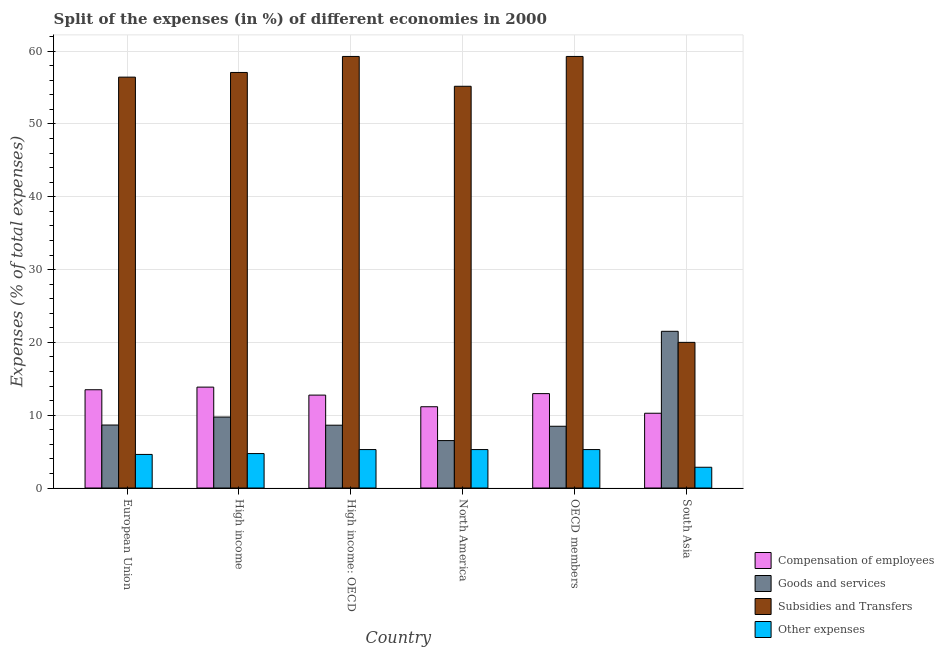How many different coloured bars are there?
Provide a succinct answer. 4. Are the number of bars per tick equal to the number of legend labels?
Offer a terse response. Yes. How many bars are there on the 6th tick from the left?
Give a very brief answer. 4. What is the percentage of amount spent on subsidies in OECD members?
Ensure brevity in your answer.  59.27. Across all countries, what is the maximum percentage of amount spent on subsidies?
Your answer should be very brief. 59.27. Across all countries, what is the minimum percentage of amount spent on goods and services?
Ensure brevity in your answer.  6.51. In which country was the percentage of amount spent on subsidies maximum?
Make the answer very short. High income: OECD. In which country was the percentage of amount spent on goods and services minimum?
Offer a very short reply. North America. What is the total percentage of amount spent on subsidies in the graph?
Your answer should be compact. 307.22. What is the difference between the percentage of amount spent on compensation of employees in North America and that in South Asia?
Your answer should be very brief. 0.89. What is the difference between the percentage of amount spent on goods and services in High income: OECD and the percentage of amount spent on compensation of employees in North America?
Offer a very short reply. -2.53. What is the average percentage of amount spent on goods and services per country?
Make the answer very short. 10.59. What is the difference between the percentage of amount spent on compensation of employees and percentage of amount spent on subsidies in European Union?
Your response must be concise. -42.94. In how many countries, is the percentage of amount spent on compensation of employees greater than 26 %?
Offer a terse response. 0. What is the ratio of the percentage of amount spent on goods and services in High income to that in High income: OECD?
Keep it short and to the point. 1.13. Is the difference between the percentage of amount spent on goods and services in High income and High income: OECD greater than the difference between the percentage of amount spent on other expenses in High income and High income: OECD?
Ensure brevity in your answer.  Yes. What is the difference between the highest and the lowest percentage of amount spent on other expenses?
Ensure brevity in your answer.  2.43. In how many countries, is the percentage of amount spent on goods and services greater than the average percentage of amount spent on goods and services taken over all countries?
Give a very brief answer. 1. What does the 4th bar from the left in North America represents?
Provide a short and direct response. Other expenses. What does the 4th bar from the right in North America represents?
Your answer should be compact. Compensation of employees. How many bars are there?
Give a very brief answer. 24. Are all the bars in the graph horizontal?
Keep it short and to the point. No. How many countries are there in the graph?
Your answer should be very brief. 6. What is the difference between two consecutive major ticks on the Y-axis?
Your response must be concise. 10. Are the values on the major ticks of Y-axis written in scientific E-notation?
Give a very brief answer. No. Does the graph contain grids?
Provide a short and direct response. Yes. What is the title of the graph?
Provide a succinct answer. Split of the expenses (in %) of different economies in 2000. What is the label or title of the Y-axis?
Keep it short and to the point. Expenses (% of total expenses). What is the Expenses (% of total expenses) of Compensation of employees in European Union?
Offer a very short reply. 13.5. What is the Expenses (% of total expenses) of Goods and services in European Union?
Offer a terse response. 8.65. What is the Expenses (% of total expenses) in Subsidies and Transfers in European Union?
Your answer should be very brief. 56.43. What is the Expenses (% of total expenses) of Other expenses in European Union?
Provide a succinct answer. 4.61. What is the Expenses (% of total expenses) of Compensation of employees in High income?
Keep it short and to the point. 13.86. What is the Expenses (% of total expenses) of Goods and services in High income?
Ensure brevity in your answer.  9.75. What is the Expenses (% of total expenses) in Subsidies and Transfers in High income?
Give a very brief answer. 57.07. What is the Expenses (% of total expenses) in Other expenses in High income?
Offer a terse response. 4.73. What is the Expenses (% of total expenses) in Compensation of employees in High income: OECD?
Provide a short and direct response. 12.76. What is the Expenses (% of total expenses) in Goods and services in High income: OECD?
Provide a succinct answer. 8.63. What is the Expenses (% of total expenses) of Subsidies and Transfers in High income: OECD?
Your response must be concise. 59.27. What is the Expenses (% of total expenses) in Other expenses in High income: OECD?
Keep it short and to the point. 5.28. What is the Expenses (% of total expenses) of Compensation of employees in North America?
Your answer should be very brief. 11.16. What is the Expenses (% of total expenses) of Goods and services in North America?
Keep it short and to the point. 6.51. What is the Expenses (% of total expenses) in Subsidies and Transfers in North America?
Give a very brief answer. 55.18. What is the Expenses (% of total expenses) in Other expenses in North America?
Make the answer very short. 5.28. What is the Expenses (% of total expenses) of Compensation of employees in OECD members?
Provide a short and direct response. 12.96. What is the Expenses (% of total expenses) in Goods and services in OECD members?
Ensure brevity in your answer.  8.48. What is the Expenses (% of total expenses) of Subsidies and Transfers in OECD members?
Your answer should be compact. 59.27. What is the Expenses (% of total expenses) of Other expenses in OECD members?
Give a very brief answer. 5.28. What is the Expenses (% of total expenses) in Compensation of employees in South Asia?
Provide a succinct answer. 10.27. What is the Expenses (% of total expenses) of Goods and services in South Asia?
Your answer should be compact. 21.52. What is the Expenses (% of total expenses) in Subsidies and Transfers in South Asia?
Offer a terse response. 20. What is the Expenses (% of total expenses) in Other expenses in South Asia?
Keep it short and to the point. 2.85. Across all countries, what is the maximum Expenses (% of total expenses) of Compensation of employees?
Provide a succinct answer. 13.86. Across all countries, what is the maximum Expenses (% of total expenses) in Goods and services?
Provide a short and direct response. 21.52. Across all countries, what is the maximum Expenses (% of total expenses) in Subsidies and Transfers?
Your answer should be very brief. 59.27. Across all countries, what is the maximum Expenses (% of total expenses) in Other expenses?
Provide a succinct answer. 5.28. Across all countries, what is the minimum Expenses (% of total expenses) of Compensation of employees?
Give a very brief answer. 10.27. Across all countries, what is the minimum Expenses (% of total expenses) of Goods and services?
Offer a very short reply. 6.51. Across all countries, what is the minimum Expenses (% of total expenses) of Subsidies and Transfers?
Provide a short and direct response. 20. Across all countries, what is the minimum Expenses (% of total expenses) in Other expenses?
Keep it short and to the point. 2.85. What is the total Expenses (% of total expenses) of Compensation of employees in the graph?
Provide a succinct answer. 74.51. What is the total Expenses (% of total expenses) in Goods and services in the graph?
Your answer should be compact. 63.54. What is the total Expenses (% of total expenses) in Subsidies and Transfers in the graph?
Offer a terse response. 307.22. What is the total Expenses (% of total expenses) of Other expenses in the graph?
Keep it short and to the point. 28.03. What is the difference between the Expenses (% of total expenses) of Compensation of employees in European Union and that in High income?
Your answer should be very brief. -0.36. What is the difference between the Expenses (% of total expenses) of Goods and services in European Union and that in High income?
Keep it short and to the point. -1.1. What is the difference between the Expenses (% of total expenses) in Subsidies and Transfers in European Union and that in High income?
Provide a succinct answer. -0.64. What is the difference between the Expenses (% of total expenses) of Other expenses in European Union and that in High income?
Ensure brevity in your answer.  -0.12. What is the difference between the Expenses (% of total expenses) of Compensation of employees in European Union and that in High income: OECD?
Keep it short and to the point. 0.74. What is the difference between the Expenses (% of total expenses) in Goods and services in European Union and that in High income: OECD?
Provide a short and direct response. 0.02. What is the difference between the Expenses (% of total expenses) of Subsidies and Transfers in European Union and that in High income: OECD?
Your answer should be very brief. -2.84. What is the difference between the Expenses (% of total expenses) in Other expenses in European Union and that in High income: OECD?
Your response must be concise. -0.67. What is the difference between the Expenses (% of total expenses) in Compensation of employees in European Union and that in North America?
Keep it short and to the point. 2.33. What is the difference between the Expenses (% of total expenses) in Goods and services in European Union and that in North America?
Your answer should be very brief. 2.14. What is the difference between the Expenses (% of total expenses) in Subsidies and Transfers in European Union and that in North America?
Offer a terse response. 1.26. What is the difference between the Expenses (% of total expenses) of Other expenses in European Union and that in North America?
Your answer should be compact. -0.67. What is the difference between the Expenses (% of total expenses) in Compensation of employees in European Union and that in OECD members?
Provide a short and direct response. 0.53. What is the difference between the Expenses (% of total expenses) of Goods and services in European Union and that in OECD members?
Offer a terse response. 0.17. What is the difference between the Expenses (% of total expenses) of Subsidies and Transfers in European Union and that in OECD members?
Provide a short and direct response. -2.84. What is the difference between the Expenses (% of total expenses) in Other expenses in European Union and that in OECD members?
Your answer should be very brief. -0.67. What is the difference between the Expenses (% of total expenses) of Compensation of employees in European Union and that in South Asia?
Offer a very short reply. 3.23. What is the difference between the Expenses (% of total expenses) of Goods and services in European Union and that in South Asia?
Offer a terse response. -12.87. What is the difference between the Expenses (% of total expenses) in Subsidies and Transfers in European Union and that in South Asia?
Your answer should be very brief. 36.43. What is the difference between the Expenses (% of total expenses) in Other expenses in European Union and that in South Asia?
Make the answer very short. 1.76. What is the difference between the Expenses (% of total expenses) in Compensation of employees in High income and that in High income: OECD?
Make the answer very short. 1.1. What is the difference between the Expenses (% of total expenses) of Goods and services in High income and that in High income: OECD?
Offer a very short reply. 1.12. What is the difference between the Expenses (% of total expenses) in Subsidies and Transfers in High income and that in High income: OECD?
Provide a short and direct response. -2.2. What is the difference between the Expenses (% of total expenses) of Other expenses in High income and that in High income: OECD?
Provide a short and direct response. -0.55. What is the difference between the Expenses (% of total expenses) of Compensation of employees in High income and that in North America?
Ensure brevity in your answer.  2.7. What is the difference between the Expenses (% of total expenses) of Goods and services in High income and that in North America?
Provide a succinct answer. 3.23. What is the difference between the Expenses (% of total expenses) of Subsidies and Transfers in High income and that in North America?
Offer a very short reply. 1.9. What is the difference between the Expenses (% of total expenses) of Other expenses in High income and that in North America?
Offer a very short reply. -0.55. What is the difference between the Expenses (% of total expenses) in Compensation of employees in High income and that in OECD members?
Your answer should be compact. 0.89. What is the difference between the Expenses (% of total expenses) of Goods and services in High income and that in OECD members?
Offer a terse response. 1.27. What is the difference between the Expenses (% of total expenses) in Subsidies and Transfers in High income and that in OECD members?
Provide a succinct answer. -2.2. What is the difference between the Expenses (% of total expenses) in Other expenses in High income and that in OECD members?
Keep it short and to the point. -0.55. What is the difference between the Expenses (% of total expenses) of Compensation of employees in High income and that in South Asia?
Make the answer very short. 3.59. What is the difference between the Expenses (% of total expenses) of Goods and services in High income and that in South Asia?
Make the answer very short. -11.77. What is the difference between the Expenses (% of total expenses) of Subsidies and Transfers in High income and that in South Asia?
Your answer should be very brief. 37.07. What is the difference between the Expenses (% of total expenses) in Other expenses in High income and that in South Asia?
Provide a short and direct response. 1.88. What is the difference between the Expenses (% of total expenses) of Compensation of employees in High income: OECD and that in North America?
Your answer should be compact. 1.6. What is the difference between the Expenses (% of total expenses) in Goods and services in High income: OECD and that in North America?
Make the answer very short. 2.11. What is the difference between the Expenses (% of total expenses) in Subsidies and Transfers in High income: OECD and that in North America?
Give a very brief answer. 4.1. What is the difference between the Expenses (% of total expenses) in Other expenses in High income: OECD and that in North America?
Offer a very short reply. 0. What is the difference between the Expenses (% of total expenses) in Compensation of employees in High income: OECD and that in OECD members?
Make the answer very short. -0.2. What is the difference between the Expenses (% of total expenses) of Goods and services in High income: OECD and that in OECD members?
Ensure brevity in your answer.  0.15. What is the difference between the Expenses (% of total expenses) in Other expenses in High income: OECD and that in OECD members?
Your answer should be compact. 0. What is the difference between the Expenses (% of total expenses) in Compensation of employees in High income: OECD and that in South Asia?
Ensure brevity in your answer.  2.49. What is the difference between the Expenses (% of total expenses) of Goods and services in High income: OECD and that in South Asia?
Provide a succinct answer. -12.89. What is the difference between the Expenses (% of total expenses) of Subsidies and Transfers in High income: OECD and that in South Asia?
Ensure brevity in your answer.  39.27. What is the difference between the Expenses (% of total expenses) of Other expenses in High income: OECD and that in South Asia?
Offer a terse response. 2.43. What is the difference between the Expenses (% of total expenses) in Compensation of employees in North America and that in OECD members?
Provide a succinct answer. -1.8. What is the difference between the Expenses (% of total expenses) of Goods and services in North America and that in OECD members?
Ensure brevity in your answer.  -1.97. What is the difference between the Expenses (% of total expenses) in Subsidies and Transfers in North America and that in OECD members?
Make the answer very short. -4.1. What is the difference between the Expenses (% of total expenses) in Compensation of employees in North America and that in South Asia?
Offer a terse response. 0.89. What is the difference between the Expenses (% of total expenses) in Goods and services in North America and that in South Asia?
Make the answer very short. -15.01. What is the difference between the Expenses (% of total expenses) in Subsidies and Transfers in North America and that in South Asia?
Offer a very short reply. 35.17. What is the difference between the Expenses (% of total expenses) of Other expenses in North America and that in South Asia?
Offer a very short reply. 2.43. What is the difference between the Expenses (% of total expenses) of Compensation of employees in OECD members and that in South Asia?
Provide a succinct answer. 2.69. What is the difference between the Expenses (% of total expenses) in Goods and services in OECD members and that in South Asia?
Your answer should be compact. -13.04. What is the difference between the Expenses (% of total expenses) of Subsidies and Transfers in OECD members and that in South Asia?
Your response must be concise. 39.27. What is the difference between the Expenses (% of total expenses) of Other expenses in OECD members and that in South Asia?
Give a very brief answer. 2.43. What is the difference between the Expenses (% of total expenses) in Compensation of employees in European Union and the Expenses (% of total expenses) in Goods and services in High income?
Keep it short and to the point. 3.75. What is the difference between the Expenses (% of total expenses) in Compensation of employees in European Union and the Expenses (% of total expenses) in Subsidies and Transfers in High income?
Provide a short and direct response. -43.58. What is the difference between the Expenses (% of total expenses) in Compensation of employees in European Union and the Expenses (% of total expenses) in Other expenses in High income?
Keep it short and to the point. 8.77. What is the difference between the Expenses (% of total expenses) in Goods and services in European Union and the Expenses (% of total expenses) in Subsidies and Transfers in High income?
Your answer should be very brief. -48.42. What is the difference between the Expenses (% of total expenses) of Goods and services in European Union and the Expenses (% of total expenses) of Other expenses in High income?
Provide a succinct answer. 3.92. What is the difference between the Expenses (% of total expenses) in Subsidies and Transfers in European Union and the Expenses (% of total expenses) in Other expenses in High income?
Offer a terse response. 51.7. What is the difference between the Expenses (% of total expenses) in Compensation of employees in European Union and the Expenses (% of total expenses) in Goods and services in High income: OECD?
Offer a very short reply. 4.87. What is the difference between the Expenses (% of total expenses) of Compensation of employees in European Union and the Expenses (% of total expenses) of Subsidies and Transfers in High income: OECD?
Provide a short and direct response. -45.77. What is the difference between the Expenses (% of total expenses) in Compensation of employees in European Union and the Expenses (% of total expenses) in Other expenses in High income: OECD?
Provide a succinct answer. 8.22. What is the difference between the Expenses (% of total expenses) in Goods and services in European Union and the Expenses (% of total expenses) in Subsidies and Transfers in High income: OECD?
Your answer should be compact. -50.62. What is the difference between the Expenses (% of total expenses) of Goods and services in European Union and the Expenses (% of total expenses) of Other expenses in High income: OECD?
Provide a short and direct response. 3.37. What is the difference between the Expenses (% of total expenses) in Subsidies and Transfers in European Union and the Expenses (% of total expenses) in Other expenses in High income: OECD?
Your response must be concise. 51.15. What is the difference between the Expenses (% of total expenses) of Compensation of employees in European Union and the Expenses (% of total expenses) of Goods and services in North America?
Your answer should be very brief. 6.98. What is the difference between the Expenses (% of total expenses) of Compensation of employees in European Union and the Expenses (% of total expenses) of Subsidies and Transfers in North America?
Offer a terse response. -41.68. What is the difference between the Expenses (% of total expenses) of Compensation of employees in European Union and the Expenses (% of total expenses) of Other expenses in North America?
Give a very brief answer. 8.22. What is the difference between the Expenses (% of total expenses) of Goods and services in European Union and the Expenses (% of total expenses) of Subsidies and Transfers in North America?
Your response must be concise. -46.53. What is the difference between the Expenses (% of total expenses) in Goods and services in European Union and the Expenses (% of total expenses) in Other expenses in North America?
Give a very brief answer. 3.37. What is the difference between the Expenses (% of total expenses) of Subsidies and Transfers in European Union and the Expenses (% of total expenses) of Other expenses in North America?
Offer a terse response. 51.15. What is the difference between the Expenses (% of total expenses) of Compensation of employees in European Union and the Expenses (% of total expenses) of Goods and services in OECD members?
Your answer should be very brief. 5.02. What is the difference between the Expenses (% of total expenses) of Compensation of employees in European Union and the Expenses (% of total expenses) of Subsidies and Transfers in OECD members?
Make the answer very short. -45.77. What is the difference between the Expenses (% of total expenses) in Compensation of employees in European Union and the Expenses (% of total expenses) in Other expenses in OECD members?
Provide a short and direct response. 8.22. What is the difference between the Expenses (% of total expenses) in Goods and services in European Union and the Expenses (% of total expenses) in Subsidies and Transfers in OECD members?
Provide a succinct answer. -50.62. What is the difference between the Expenses (% of total expenses) of Goods and services in European Union and the Expenses (% of total expenses) of Other expenses in OECD members?
Make the answer very short. 3.37. What is the difference between the Expenses (% of total expenses) in Subsidies and Transfers in European Union and the Expenses (% of total expenses) in Other expenses in OECD members?
Your answer should be compact. 51.15. What is the difference between the Expenses (% of total expenses) of Compensation of employees in European Union and the Expenses (% of total expenses) of Goods and services in South Asia?
Ensure brevity in your answer.  -8.03. What is the difference between the Expenses (% of total expenses) in Compensation of employees in European Union and the Expenses (% of total expenses) in Subsidies and Transfers in South Asia?
Keep it short and to the point. -6.51. What is the difference between the Expenses (% of total expenses) in Compensation of employees in European Union and the Expenses (% of total expenses) in Other expenses in South Asia?
Ensure brevity in your answer.  10.65. What is the difference between the Expenses (% of total expenses) in Goods and services in European Union and the Expenses (% of total expenses) in Subsidies and Transfers in South Asia?
Your response must be concise. -11.35. What is the difference between the Expenses (% of total expenses) of Goods and services in European Union and the Expenses (% of total expenses) of Other expenses in South Asia?
Make the answer very short. 5.8. What is the difference between the Expenses (% of total expenses) of Subsidies and Transfers in European Union and the Expenses (% of total expenses) of Other expenses in South Asia?
Provide a succinct answer. 53.58. What is the difference between the Expenses (% of total expenses) in Compensation of employees in High income and the Expenses (% of total expenses) in Goods and services in High income: OECD?
Offer a very short reply. 5.23. What is the difference between the Expenses (% of total expenses) in Compensation of employees in High income and the Expenses (% of total expenses) in Subsidies and Transfers in High income: OECD?
Your response must be concise. -45.41. What is the difference between the Expenses (% of total expenses) in Compensation of employees in High income and the Expenses (% of total expenses) in Other expenses in High income: OECD?
Provide a short and direct response. 8.58. What is the difference between the Expenses (% of total expenses) of Goods and services in High income and the Expenses (% of total expenses) of Subsidies and Transfers in High income: OECD?
Your answer should be very brief. -49.52. What is the difference between the Expenses (% of total expenses) of Goods and services in High income and the Expenses (% of total expenses) of Other expenses in High income: OECD?
Offer a terse response. 4.47. What is the difference between the Expenses (% of total expenses) in Subsidies and Transfers in High income and the Expenses (% of total expenses) in Other expenses in High income: OECD?
Ensure brevity in your answer.  51.79. What is the difference between the Expenses (% of total expenses) in Compensation of employees in High income and the Expenses (% of total expenses) in Goods and services in North America?
Your answer should be compact. 7.34. What is the difference between the Expenses (% of total expenses) of Compensation of employees in High income and the Expenses (% of total expenses) of Subsidies and Transfers in North America?
Your response must be concise. -41.32. What is the difference between the Expenses (% of total expenses) of Compensation of employees in High income and the Expenses (% of total expenses) of Other expenses in North America?
Your answer should be compact. 8.58. What is the difference between the Expenses (% of total expenses) in Goods and services in High income and the Expenses (% of total expenses) in Subsidies and Transfers in North America?
Offer a terse response. -45.43. What is the difference between the Expenses (% of total expenses) of Goods and services in High income and the Expenses (% of total expenses) of Other expenses in North America?
Keep it short and to the point. 4.47. What is the difference between the Expenses (% of total expenses) in Subsidies and Transfers in High income and the Expenses (% of total expenses) in Other expenses in North America?
Your answer should be very brief. 51.79. What is the difference between the Expenses (% of total expenses) in Compensation of employees in High income and the Expenses (% of total expenses) in Goods and services in OECD members?
Give a very brief answer. 5.38. What is the difference between the Expenses (% of total expenses) in Compensation of employees in High income and the Expenses (% of total expenses) in Subsidies and Transfers in OECD members?
Your answer should be very brief. -45.41. What is the difference between the Expenses (% of total expenses) of Compensation of employees in High income and the Expenses (% of total expenses) of Other expenses in OECD members?
Keep it short and to the point. 8.58. What is the difference between the Expenses (% of total expenses) in Goods and services in High income and the Expenses (% of total expenses) in Subsidies and Transfers in OECD members?
Provide a succinct answer. -49.52. What is the difference between the Expenses (% of total expenses) of Goods and services in High income and the Expenses (% of total expenses) of Other expenses in OECD members?
Provide a succinct answer. 4.47. What is the difference between the Expenses (% of total expenses) in Subsidies and Transfers in High income and the Expenses (% of total expenses) in Other expenses in OECD members?
Offer a very short reply. 51.79. What is the difference between the Expenses (% of total expenses) of Compensation of employees in High income and the Expenses (% of total expenses) of Goods and services in South Asia?
Provide a short and direct response. -7.66. What is the difference between the Expenses (% of total expenses) of Compensation of employees in High income and the Expenses (% of total expenses) of Subsidies and Transfers in South Asia?
Give a very brief answer. -6.15. What is the difference between the Expenses (% of total expenses) in Compensation of employees in High income and the Expenses (% of total expenses) in Other expenses in South Asia?
Make the answer very short. 11.01. What is the difference between the Expenses (% of total expenses) of Goods and services in High income and the Expenses (% of total expenses) of Subsidies and Transfers in South Asia?
Offer a terse response. -10.26. What is the difference between the Expenses (% of total expenses) in Goods and services in High income and the Expenses (% of total expenses) in Other expenses in South Asia?
Keep it short and to the point. 6.9. What is the difference between the Expenses (% of total expenses) in Subsidies and Transfers in High income and the Expenses (% of total expenses) in Other expenses in South Asia?
Ensure brevity in your answer.  54.22. What is the difference between the Expenses (% of total expenses) of Compensation of employees in High income: OECD and the Expenses (% of total expenses) of Goods and services in North America?
Your answer should be compact. 6.25. What is the difference between the Expenses (% of total expenses) of Compensation of employees in High income: OECD and the Expenses (% of total expenses) of Subsidies and Transfers in North America?
Provide a succinct answer. -42.41. What is the difference between the Expenses (% of total expenses) of Compensation of employees in High income: OECD and the Expenses (% of total expenses) of Other expenses in North America?
Provide a succinct answer. 7.48. What is the difference between the Expenses (% of total expenses) of Goods and services in High income: OECD and the Expenses (% of total expenses) of Subsidies and Transfers in North America?
Provide a succinct answer. -46.55. What is the difference between the Expenses (% of total expenses) in Goods and services in High income: OECD and the Expenses (% of total expenses) in Other expenses in North America?
Offer a terse response. 3.35. What is the difference between the Expenses (% of total expenses) of Subsidies and Transfers in High income: OECD and the Expenses (% of total expenses) of Other expenses in North America?
Keep it short and to the point. 53.99. What is the difference between the Expenses (% of total expenses) of Compensation of employees in High income: OECD and the Expenses (% of total expenses) of Goods and services in OECD members?
Keep it short and to the point. 4.28. What is the difference between the Expenses (% of total expenses) of Compensation of employees in High income: OECD and the Expenses (% of total expenses) of Subsidies and Transfers in OECD members?
Your response must be concise. -46.51. What is the difference between the Expenses (% of total expenses) of Compensation of employees in High income: OECD and the Expenses (% of total expenses) of Other expenses in OECD members?
Provide a short and direct response. 7.48. What is the difference between the Expenses (% of total expenses) in Goods and services in High income: OECD and the Expenses (% of total expenses) in Subsidies and Transfers in OECD members?
Your response must be concise. -50.64. What is the difference between the Expenses (% of total expenses) in Goods and services in High income: OECD and the Expenses (% of total expenses) in Other expenses in OECD members?
Your answer should be compact. 3.35. What is the difference between the Expenses (% of total expenses) of Subsidies and Transfers in High income: OECD and the Expenses (% of total expenses) of Other expenses in OECD members?
Your answer should be very brief. 53.99. What is the difference between the Expenses (% of total expenses) of Compensation of employees in High income: OECD and the Expenses (% of total expenses) of Goods and services in South Asia?
Ensure brevity in your answer.  -8.76. What is the difference between the Expenses (% of total expenses) of Compensation of employees in High income: OECD and the Expenses (% of total expenses) of Subsidies and Transfers in South Asia?
Keep it short and to the point. -7.24. What is the difference between the Expenses (% of total expenses) in Compensation of employees in High income: OECD and the Expenses (% of total expenses) in Other expenses in South Asia?
Your answer should be very brief. 9.91. What is the difference between the Expenses (% of total expenses) in Goods and services in High income: OECD and the Expenses (% of total expenses) in Subsidies and Transfers in South Asia?
Give a very brief answer. -11.38. What is the difference between the Expenses (% of total expenses) of Goods and services in High income: OECD and the Expenses (% of total expenses) of Other expenses in South Asia?
Keep it short and to the point. 5.78. What is the difference between the Expenses (% of total expenses) in Subsidies and Transfers in High income: OECD and the Expenses (% of total expenses) in Other expenses in South Asia?
Provide a succinct answer. 56.42. What is the difference between the Expenses (% of total expenses) of Compensation of employees in North America and the Expenses (% of total expenses) of Goods and services in OECD members?
Your answer should be compact. 2.68. What is the difference between the Expenses (% of total expenses) of Compensation of employees in North America and the Expenses (% of total expenses) of Subsidies and Transfers in OECD members?
Offer a very short reply. -48.11. What is the difference between the Expenses (% of total expenses) in Compensation of employees in North America and the Expenses (% of total expenses) in Other expenses in OECD members?
Keep it short and to the point. 5.88. What is the difference between the Expenses (% of total expenses) in Goods and services in North America and the Expenses (% of total expenses) in Subsidies and Transfers in OECD members?
Ensure brevity in your answer.  -52.76. What is the difference between the Expenses (% of total expenses) in Goods and services in North America and the Expenses (% of total expenses) in Other expenses in OECD members?
Offer a terse response. 1.23. What is the difference between the Expenses (% of total expenses) in Subsidies and Transfers in North America and the Expenses (% of total expenses) in Other expenses in OECD members?
Offer a terse response. 49.9. What is the difference between the Expenses (% of total expenses) of Compensation of employees in North America and the Expenses (% of total expenses) of Goods and services in South Asia?
Ensure brevity in your answer.  -10.36. What is the difference between the Expenses (% of total expenses) of Compensation of employees in North America and the Expenses (% of total expenses) of Subsidies and Transfers in South Asia?
Ensure brevity in your answer.  -8.84. What is the difference between the Expenses (% of total expenses) of Compensation of employees in North America and the Expenses (% of total expenses) of Other expenses in South Asia?
Provide a succinct answer. 8.31. What is the difference between the Expenses (% of total expenses) of Goods and services in North America and the Expenses (% of total expenses) of Subsidies and Transfers in South Asia?
Offer a very short reply. -13.49. What is the difference between the Expenses (% of total expenses) in Goods and services in North America and the Expenses (% of total expenses) in Other expenses in South Asia?
Your answer should be very brief. 3.66. What is the difference between the Expenses (% of total expenses) in Subsidies and Transfers in North America and the Expenses (% of total expenses) in Other expenses in South Asia?
Give a very brief answer. 52.33. What is the difference between the Expenses (% of total expenses) of Compensation of employees in OECD members and the Expenses (% of total expenses) of Goods and services in South Asia?
Give a very brief answer. -8.56. What is the difference between the Expenses (% of total expenses) in Compensation of employees in OECD members and the Expenses (% of total expenses) in Subsidies and Transfers in South Asia?
Offer a terse response. -7.04. What is the difference between the Expenses (% of total expenses) in Compensation of employees in OECD members and the Expenses (% of total expenses) in Other expenses in South Asia?
Ensure brevity in your answer.  10.11. What is the difference between the Expenses (% of total expenses) in Goods and services in OECD members and the Expenses (% of total expenses) in Subsidies and Transfers in South Asia?
Your answer should be very brief. -11.52. What is the difference between the Expenses (% of total expenses) of Goods and services in OECD members and the Expenses (% of total expenses) of Other expenses in South Asia?
Provide a short and direct response. 5.63. What is the difference between the Expenses (% of total expenses) of Subsidies and Transfers in OECD members and the Expenses (% of total expenses) of Other expenses in South Asia?
Your answer should be very brief. 56.42. What is the average Expenses (% of total expenses) of Compensation of employees per country?
Provide a succinct answer. 12.42. What is the average Expenses (% of total expenses) in Goods and services per country?
Your response must be concise. 10.59. What is the average Expenses (% of total expenses) of Subsidies and Transfers per country?
Ensure brevity in your answer.  51.2. What is the average Expenses (% of total expenses) of Other expenses per country?
Provide a short and direct response. 4.67. What is the difference between the Expenses (% of total expenses) in Compensation of employees and Expenses (% of total expenses) in Goods and services in European Union?
Give a very brief answer. 4.85. What is the difference between the Expenses (% of total expenses) of Compensation of employees and Expenses (% of total expenses) of Subsidies and Transfers in European Union?
Provide a succinct answer. -42.94. What is the difference between the Expenses (% of total expenses) of Compensation of employees and Expenses (% of total expenses) of Other expenses in European Union?
Offer a terse response. 8.88. What is the difference between the Expenses (% of total expenses) in Goods and services and Expenses (% of total expenses) in Subsidies and Transfers in European Union?
Ensure brevity in your answer.  -47.78. What is the difference between the Expenses (% of total expenses) in Goods and services and Expenses (% of total expenses) in Other expenses in European Union?
Your answer should be very brief. 4.04. What is the difference between the Expenses (% of total expenses) in Subsidies and Transfers and Expenses (% of total expenses) in Other expenses in European Union?
Provide a short and direct response. 51.82. What is the difference between the Expenses (% of total expenses) in Compensation of employees and Expenses (% of total expenses) in Goods and services in High income?
Your response must be concise. 4.11. What is the difference between the Expenses (% of total expenses) of Compensation of employees and Expenses (% of total expenses) of Subsidies and Transfers in High income?
Your answer should be compact. -43.22. What is the difference between the Expenses (% of total expenses) of Compensation of employees and Expenses (% of total expenses) of Other expenses in High income?
Your answer should be very brief. 9.13. What is the difference between the Expenses (% of total expenses) of Goods and services and Expenses (% of total expenses) of Subsidies and Transfers in High income?
Offer a very short reply. -47.33. What is the difference between the Expenses (% of total expenses) of Goods and services and Expenses (% of total expenses) of Other expenses in High income?
Your answer should be very brief. 5.02. What is the difference between the Expenses (% of total expenses) of Subsidies and Transfers and Expenses (% of total expenses) of Other expenses in High income?
Ensure brevity in your answer.  52.34. What is the difference between the Expenses (% of total expenses) in Compensation of employees and Expenses (% of total expenses) in Goods and services in High income: OECD?
Provide a succinct answer. 4.13. What is the difference between the Expenses (% of total expenses) in Compensation of employees and Expenses (% of total expenses) in Subsidies and Transfers in High income: OECD?
Offer a very short reply. -46.51. What is the difference between the Expenses (% of total expenses) of Compensation of employees and Expenses (% of total expenses) of Other expenses in High income: OECD?
Offer a terse response. 7.48. What is the difference between the Expenses (% of total expenses) in Goods and services and Expenses (% of total expenses) in Subsidies and Transfers in High income: OECD?
Your answer should be very brief. -50.64. What is the difference between the Expenses (% of total expenses) of Goods and services and Expenses (% of total expenses) of Other expenses in High income: OECD?
Keep it short and to the point. 3.35. What is the difference between the Expenses (% of total expenses) of Subsidies and Transfers and Expenses (% of total expenses) of Other expenses in High income: OECD?
Your response must be concise. 53.99. What is the difference between the Expenses (% of total expenses) of Compensation of employees and Expenses (% of total expenses) of Goods and services in North America?
Your answer should be very brief. 4.65. What is the difference between the Expenses (% of total expenses) in Compensation of employees and Expenses (% of total expenses) in Subsidies and Transfers in North America?
Ensure brevity in your answer.  -44.01. What is the difference between the Expenses (% of total expenses) of Compensation of employees and Expenses (% of total expenses) of Other expenses in North America?
Your response must be concise. 5.88. What is the difference between the Expenses (% of total expenses) of Goods and services and Expenses (% of total expenses) of Subsidies and Transfers in North America?
Provide a succinct answer. -48.66. What is the difference between the Expenses (% of total expenses) in Goods and services and Expenses (% of total expenses) in Other expenses in North America?
Keep it short and to the point. 1.23. What is the difference between the Expenses (% of total expenses) in Subsidies and Transfers and Expenses (% of total expenses) in Other expenses in North America?
Keep it short and to the point. 49.9. What is the difference between the Expenses (% of total expenses) in Compensation of employees and Expenses (% of total expenses) in Goods and services in OECD members?
Give a very brief answer. 4.48. What is the difference between the Expenses (% of total expenses) in Compensation of employees and Expenses (% of total expenses) in Subsidies and Transfers in OECD members?
Offer a terse response. -46.31. What is the difference between the Expenses (% of total expenses) in Compensation of employees and Expenses (% of total expenses) in Other expenses in OECD members?
Keep it short and to the point. 7.68. What is the difference between the Expenses (% of total expenses) in Goods and services and Expenses (% of total expenses) in Subsidies and Transfers in OECD members?
Make the answer very short. -50.79. What is the difference between the Expenses (% of total expenses) in Goods and services and Expenses (% of total expenses) in Other expenses in OECD members?
Your answer should be very brief. 3.2. What is the difference between the Expenses (% of total expenses) of Subsidies and Transfers and Expenses (% of total expenses) of Other expenses in OECD members?
Provide a succinct answer. 53.99. What is the difference between the Expenses (% of total expenses) of Compensation of employees and Expenses (% of total expenses) of Goods and services in South Asia?
Make the answer very short. -11.25. What is the difference between the Expenses (% of total expenses) in Compensation of employees and Expenses (% of total expenses) in Subsidies and Transfers in South Asia?
Keep it short and to the point. -9.73. What is the difference between the Expenses (% of total expenses) of Compensation of employees and Expenses (% of total expenses) of Other expenses in South Asia?
Make the answer very short. 7.42. What is the difference between the Expenses (% of total expenses) of Goods and services and Expenses (% of total expenses) of Subsidies and Transfers in South Asia?
Offer a very short reply. 1.52. What is the difference between the Expenses (% of total expenses) in Goods and services and Expenses (% of total expenses) in Other expenses in South Asia?
Your answer should be very brief. 18.67. What is the difference between the Expenses (% of total expenses) in Subsidies and Transfers and Expenses (% of total expenses) in Other expenses in South Asia?
Offer a very short reply. 17.15. What is the ratio of the Expenses (% of total expenses) of Compensation of employees in European Union to that in High income?
Your answer should be compact. 0.97. What is the ratio of the Expenses (% of total expenses) in Goods and services in European Union to that in High income?
Your answer should be very brief. 0.89. What is the ratio of the Expenses (% of total expenses) in Other expenses in European Union to that in High income?
Your answer should be compact. 0.98. What is the ratio of the Expenses (% of total expenses) of Compensation of employees in European Union to that in High income: OECD?
Ensure brevity in your answer.  1.06. What is the ratio of the Expenses (% of total expenses) in Subsidies and Transfers in European Union to that in High income: OECD?
Your answer should be very brief. 0.95. What is the ratio of the Expenses (% of total expenses) of Other expenses in European Union to that in High income: OECD?
Your response must be concise. 0.87. What is the ratio of the Expenses (% of total expenses) in Compensation of employees in European Union to that in North America?
Ensure brevity in your answer.  1.21. What is the ratio of the Expenses (% of total expenses) in Goods and services in European Union to that in North America?
Ensure brevity in your answer.  1.33. What is the ratio of the Expenses (% of total expenses) of Subsidies and Transfers in European Union to that in North America?
Offer a terse response. 1.02. What is the ratio of the Expenses (% of total expenses) of Other expenses in European Union to that in North America?
Offer a very short reply. 0.87. What is the ratio of the Expenses (% of total expenses) in Compensation of employees in European Union to that in OECD members?
Ensure brevity in your answer.  1.04. What is the ratio of the Expenses (% of total expenses) in Goods and services in European Union to that in OECD members?
Your answer should be very brief. 1.02. What is the ratio of the Expenses (% of total expenses) in Subsidies and Transfers in European Union to that in OECD members?
Your answer should be very brief. 0.95. What is the ratio of the Expenses (% of total expenses) of Other expenses in European Union to that in OECD members?
Provide a short and direct response. 0.87. What is the ratio of the Expenses (% of total expenses) of Compensation of employees in European Union to that in South Asia?
Your answer should be compact. 1.31. What is the ratio of the Expenses (% of total expenses) in Goods and services in European Union to that in South Asia?
Keep it short and to the point. 0.4. What is the ratio of the Expenses (% of total expenses) of Subsidies and Transfers in European Union to that in South Asia?
Your answer should be compact. 2.82. What is the ratio of the Expenses (% of total expenses) of Other expenses in European Union to that in South Asia?
Keep it short and to the point. 1.62. What is the ratio of the Expenses (% of total expenses) in Compensation of employees in High income to that in High income: OECD?
Provide a short and direct response. 1.09. What is the ratio of the Expenses (% of total expenses) of Goods and services in High income to that in High income: OECD?
Offer a terse response. 1.13. What is the ratio of the Expenses (% of total expenses) in Subsidies and Transfers in High income to that in High income: OECD?
Provide a short and direct response. 0.96. What is the ratio of the Expenses (% of total expenses) of Other expenses in High income to that in High income: OECD?
Ensure brevity in your answer.  0.9. What is the ratio of the Expenses (% of total expenses) in Compensation of employees in High income to that in North America?
Your answer should be very brief. 1.24. What is the ratio of the Expenses (% of total expenses) of Goods and services in High income to that in North America?
Provide a short and direct response. 1.5. What is the ratio of the Expenses (% of total expenses) in Subsidies and Transfers in High income to that in North America?
Your answer should be compact. 1.03. What is the ratio of the Expenses (% of total expenses) in Other expenses in High income to that in North America?
Offer a terse response. 0.9. What is the ratio of the Expenses (% of total expenses) of Compensation of employees in High income to that in OECD members?
Your response must be concise. 1.07. What is the ratio of the Expenses (% of total expenses) of Goods and services in High income to that in OECD members?
Offer a very short reply. 1.15. What is the ratio of the Expenses (% of total expenses) in Subsidies and Transfers in High income to that in OECD members?
Your answer should be very brief. 0.96. What is the ratio of the Expenses (% of total expenses) in Other expenses in High income to that in OECD members?
Give a very brief answer. 0.9. What is the ratio of the Expenses (% of total expenses) of Compensation of employees in High income to that in South Asia?
Your answer should be compact. 1.35. What is the ratio of the Expenses (% of total expenses) in Goods and services in High income to that in South Asia?
Give a very brief answer. 0.45. What is the ratio of the Expenses (% of total expenses) of Subsidies and Transfers in High income to that in South Asia?
Ensure brevity in your answer.  2.85. What is the ratio of the Expenses (% of total expenses) of Other expenses in High income to that in South Asia?
Make the answer very short. 1.66. What is the ratio of the Expenses (% of total expenses) in Compensation of employees in High income: OECD to that in North America?
Your response must be concise. 1.14. What is the ratio of the Expenses (% of total expenses) in Goods and services in High income: OECD to that in North America?
Ensure brevity in your answer.  1.32. What is the ratio of the Expenses (% of total expenses) of Subsidies and Transfers in High income: OECD to that in North America?
Make the answer very short. 1.07. What is the ratio of the Expenses (% of total expenses) in Other expenses in High income: OECD to that in North America?
Keep it short and to the point. 1. What is the ratio of the Expenses (% of total expenses) in Compensation of employees in High income: OECD to that in OECD members?
Your answer should be compact. 0.98. What is the ratio of the Expenses (% of total expenses) of Goods and services in High income: OECD to that in OECD members?
Give a very brief answer. 1.02. What is the ratio of the Expenses (% of total expenses) of Subsidies and Transfers in High income: OECD to that in OECD members?
Provide a short and direct response. 1. What is the ratio of the Expenses (% of total expenses) in Other expenses in High income: OECD to that in OECD members?
Your answer should be very brief. 1. What is the ratio of the Expenses (% of total expenses) in Compensation of employees in High income: OECD to that in South Asia?
Ensure brevity in your answer.  1.24. What is the ratio of the Expenses (% of total expenses) of Goods and services in High income: OECD to that in South Asia?
Offer a terse response. 0.4. What is the ratio of the Expenses (% of total expenses) of Subsidies and Transfers in High income: OECD to that in South Asia?
Your answer should be very brief. 2.96. What is the ratio of the Expenses (% of total expenses) in Other expenses in High income: OECD to that in South Asia?
Offer a very short reply. 1.85. What is the ratio of the Expenses (% of total expenses) in Compensation of employees in North America to that in OECD members?
Provide a succinct answer. 0.86. What is the ratio of the Expenses (% of total expenses) in Goods and services in North America to that in OECD members?
Your response must be concise. 0.77. What is the ratio of the Expenses (% of total expenses) in Subsidies and Transfers in North America to that in OECD members?
Your answer should be very brief. 0.93. What is the ratio of the Expenses (% of total expenses) of Compensation of employees in North America to that in South Asia?
Ensure brevity in your answer.  1.09. What is the ratio of the Expenses (% of total expenses) in Goods and services in North America to that in South Asia?
Your answer should be compact. 0.3. What is the ratio of the Expenses (% of total expenses) of Subsidies and Transfers in North America to that in South Asia?
Make the answer very short. 2.76. What is the ratio of the Expenses (% of total expenses) in Other expenses in North America to that in South Asia?
Your answer should be compact. 1.85. What is the ratio of the Expenses (% of total expenses) of Compensation of employees in OECD members to that in South Asia?
Ensure brevity in your answer.  1.26. What is the ratio of the Expenses (% of total expenses) of Goods and services in OECD members to that in South Asia?
Offer a very short reply. 0.39. What is the ratio of the Expenses (% of total expenses) of Subsidies and Transfers in OECD members to that in South Asia?
Make the answer very short. 2.96. What is the ratio of the Expenses (% of total expenses) in Other expenses in OECD members to that in South Asia?
Offer a very short reply. 1.85. What is the difference between the highest and the second highest Expenses (% of total expenses) in Compensation of employees?
Make the answer very short. 0.36. What is the difference between the highest and the second highest Expenses (% of total expenses) of Goods and services?
Make the answer very short. 11.77. What is the difference between the highest and the second highest Expenses (% of total expenses) in Other expenses?
Provide a succinct answer. 0. What is the difference between the highest and the lowest Expenses (% of total expenses) of Compensation of employees?
Your answer should be very brief. 3.59. What is the difference between the highest and the lowest Expenses (% of total expenses) of Goods and services?
Provide a succinct answer. 15.01. What is the difference between the highest and the lowest Expenses (% of total expenses) in Subsidies and Transfers?
Make the answer very short. 39.27. What is the difference between the highest and the lowest Expenses (% of total expenses) in Other expenses?
Your answer should be very brief. 2.43. 